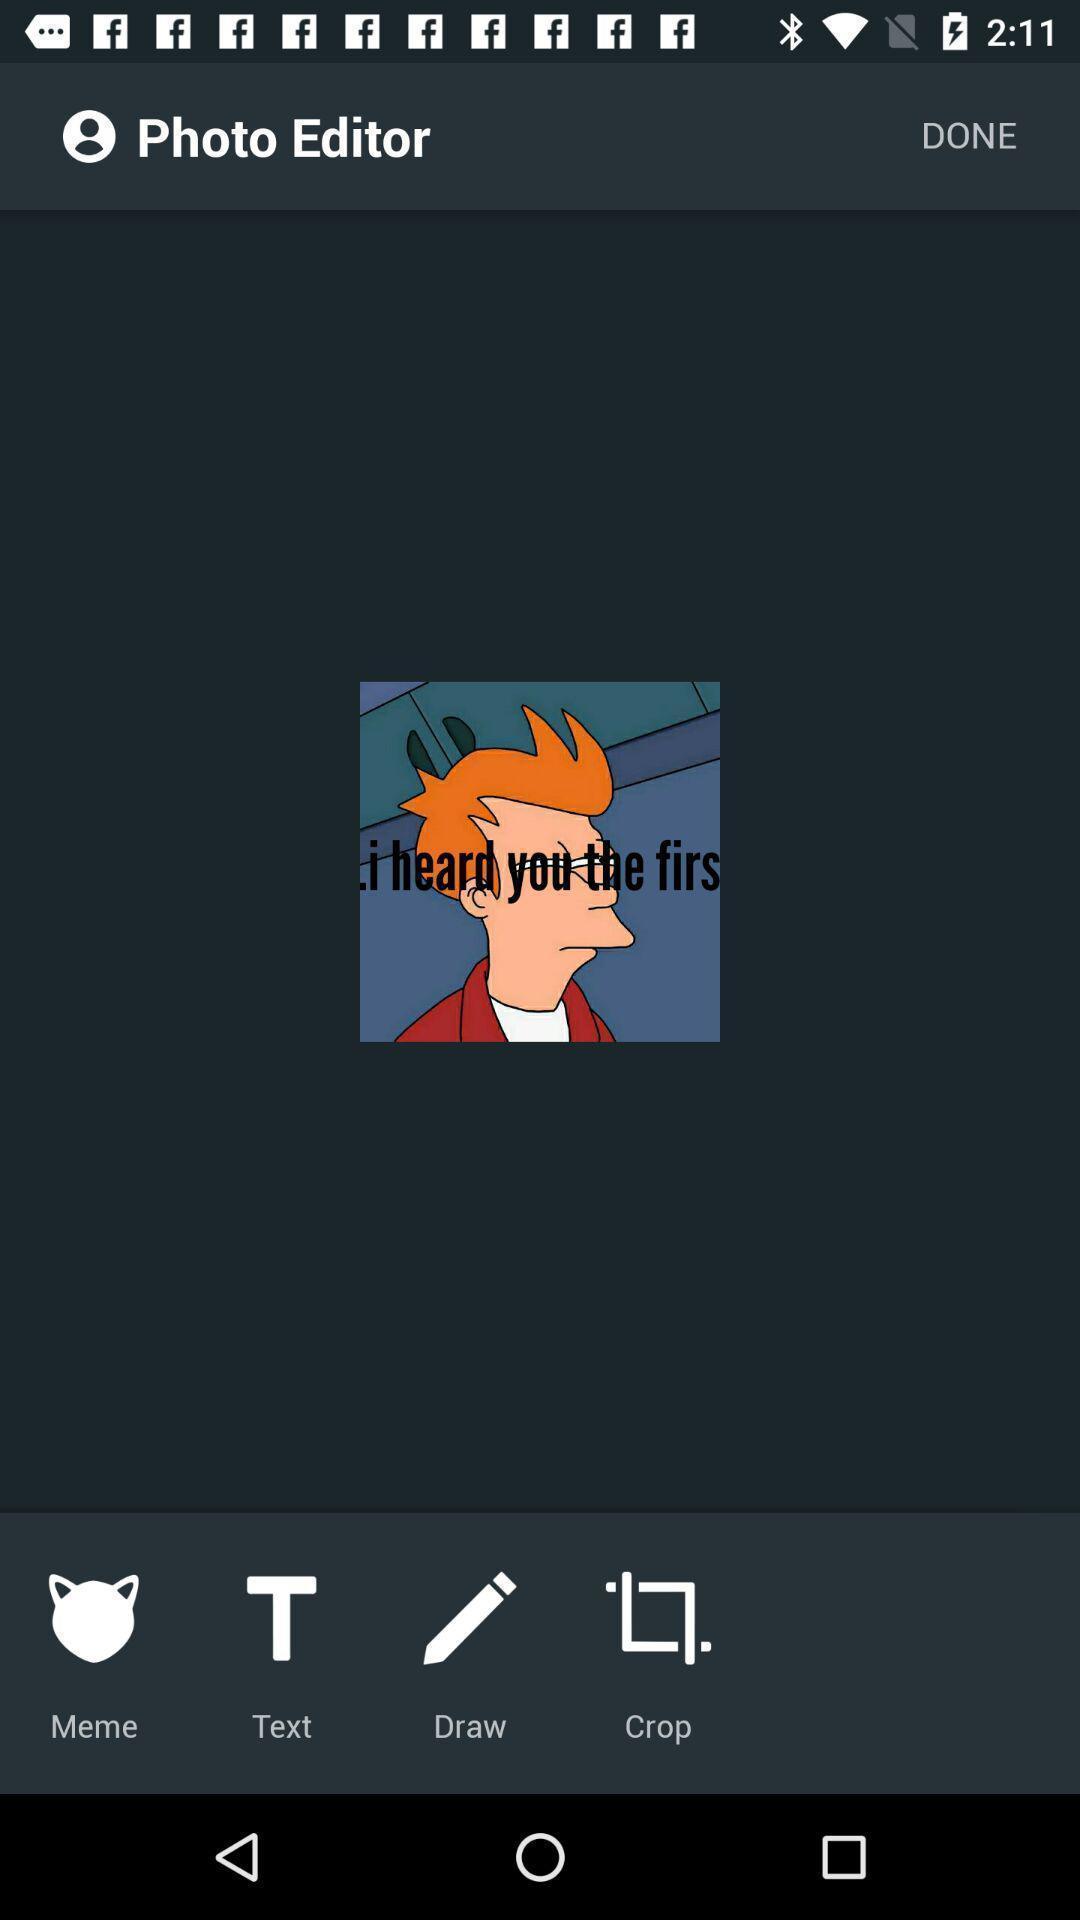Provide a detailed account of this screenshot. Screen displaying various tools for photo editing. 